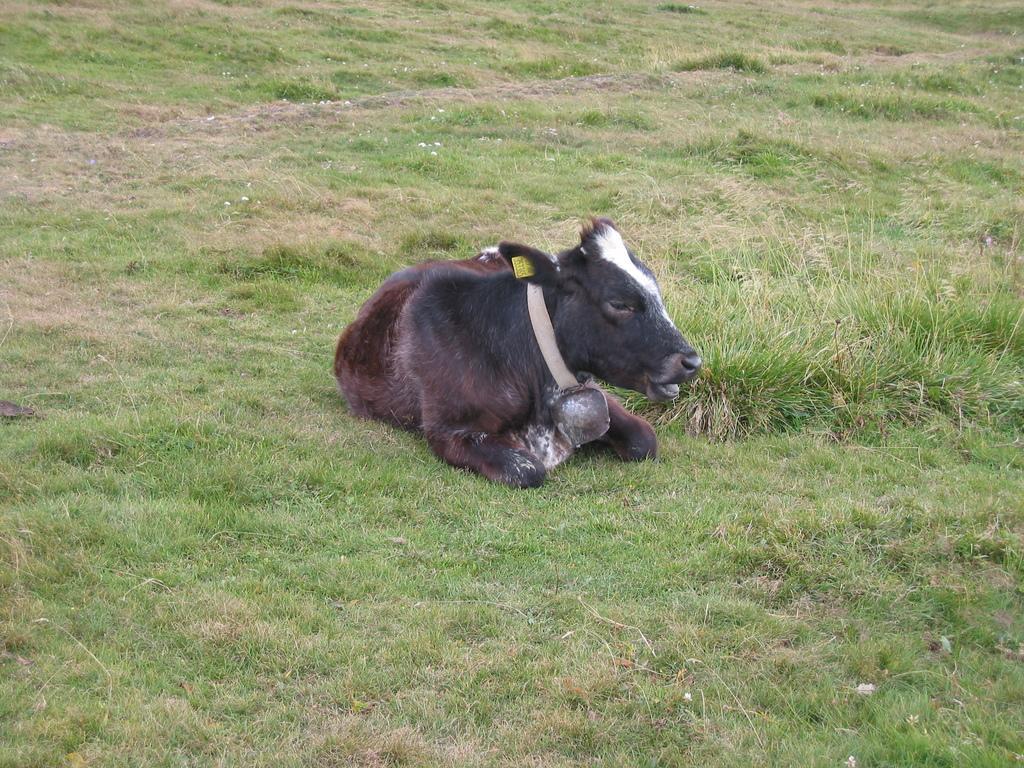Describe this image in one or two sentences. In this picture we can see black color cow baby sitting in the grass ground. 